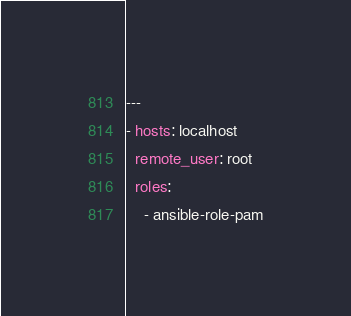<code> <loc_0><loc_0><loc_500><loc_500><_YAML_>---
- hosts: localhost
  remote_user: root
  roles:
    - ansible-role-pam</code> 